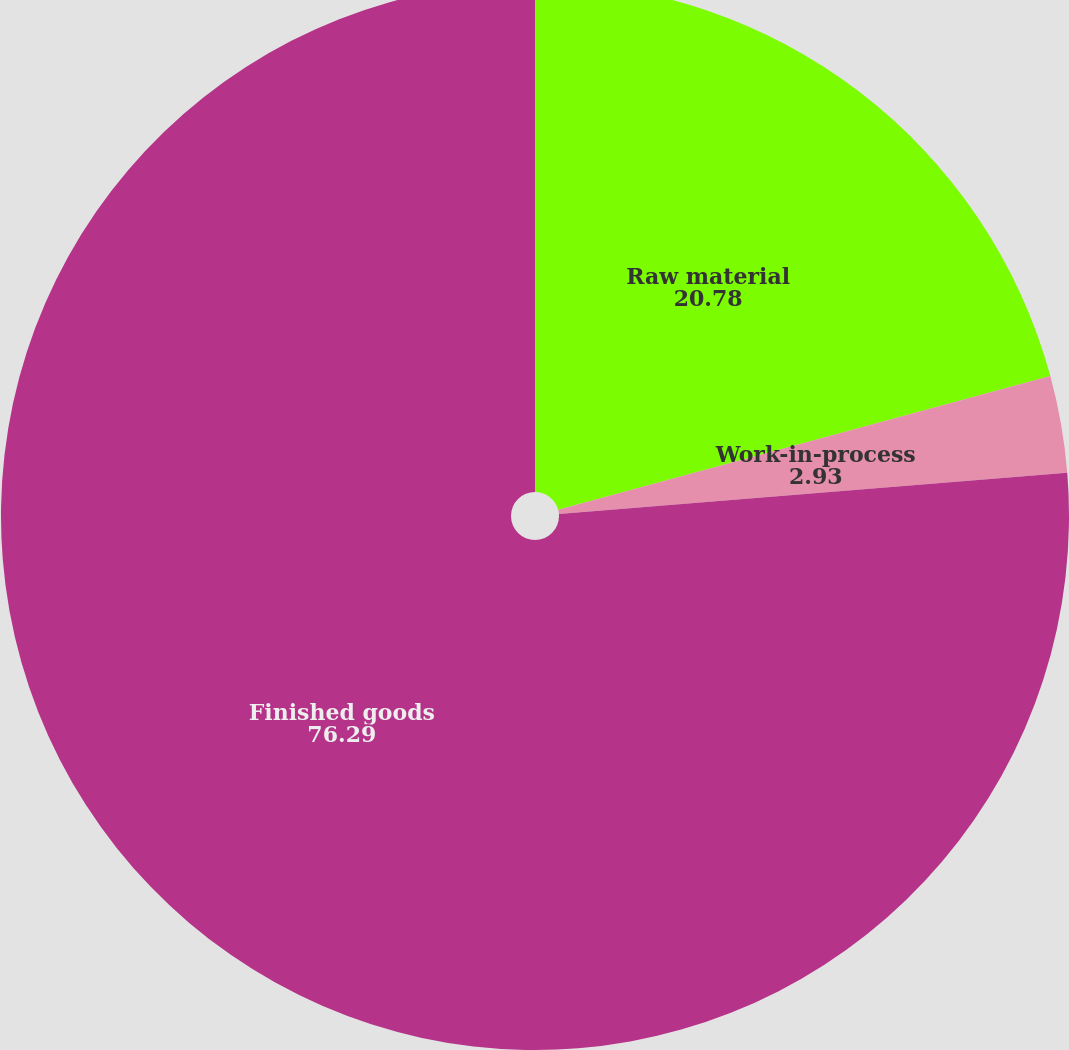Convert chart. <chart><loc_0><loc_0><loc_500><loc_500><pie_chart><fcel>Raw material<fcel>Work-in-process<fcel>Finished goods<nl><fcel>20.78%<fcel>2.93%<fcel>76.29%<nl></chart> 